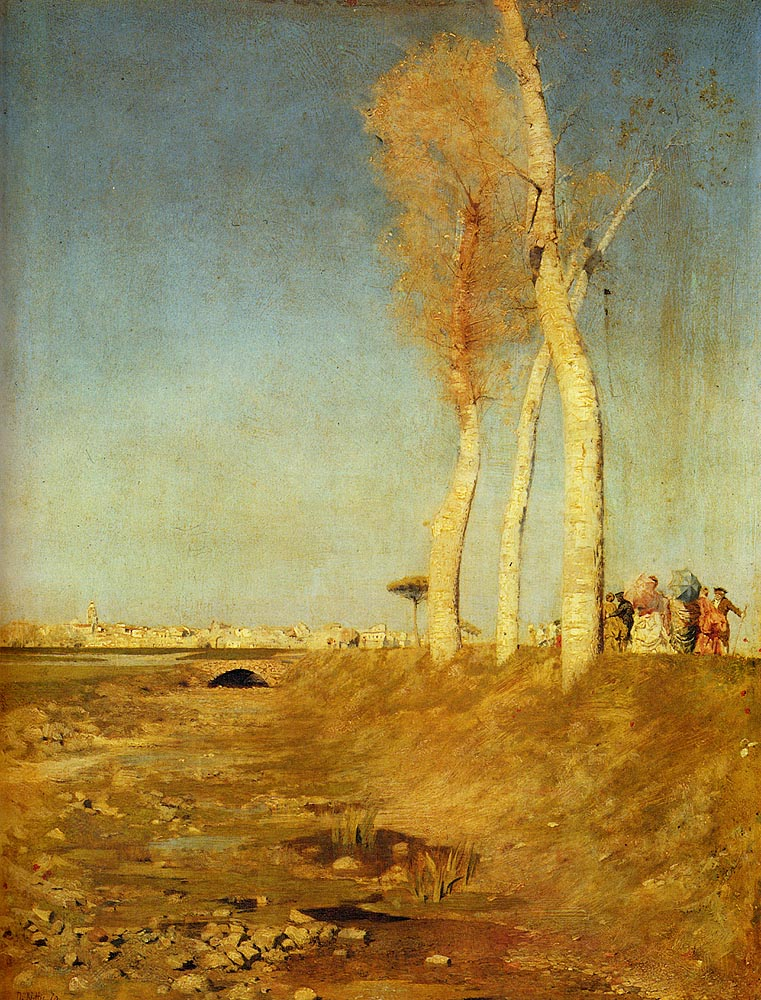What does the presence of birch trees symbolize in this landscape? The birch trees in 'The Lackawanna Valley' symbolize resilience and adaptability, reflecting the ability of nature to endure amidst the environmental changes triggered by industrialization. Their prominent placement in the barren landscape also draws attention to the contrast between the natural world and the encroaching industrial backdrop. 